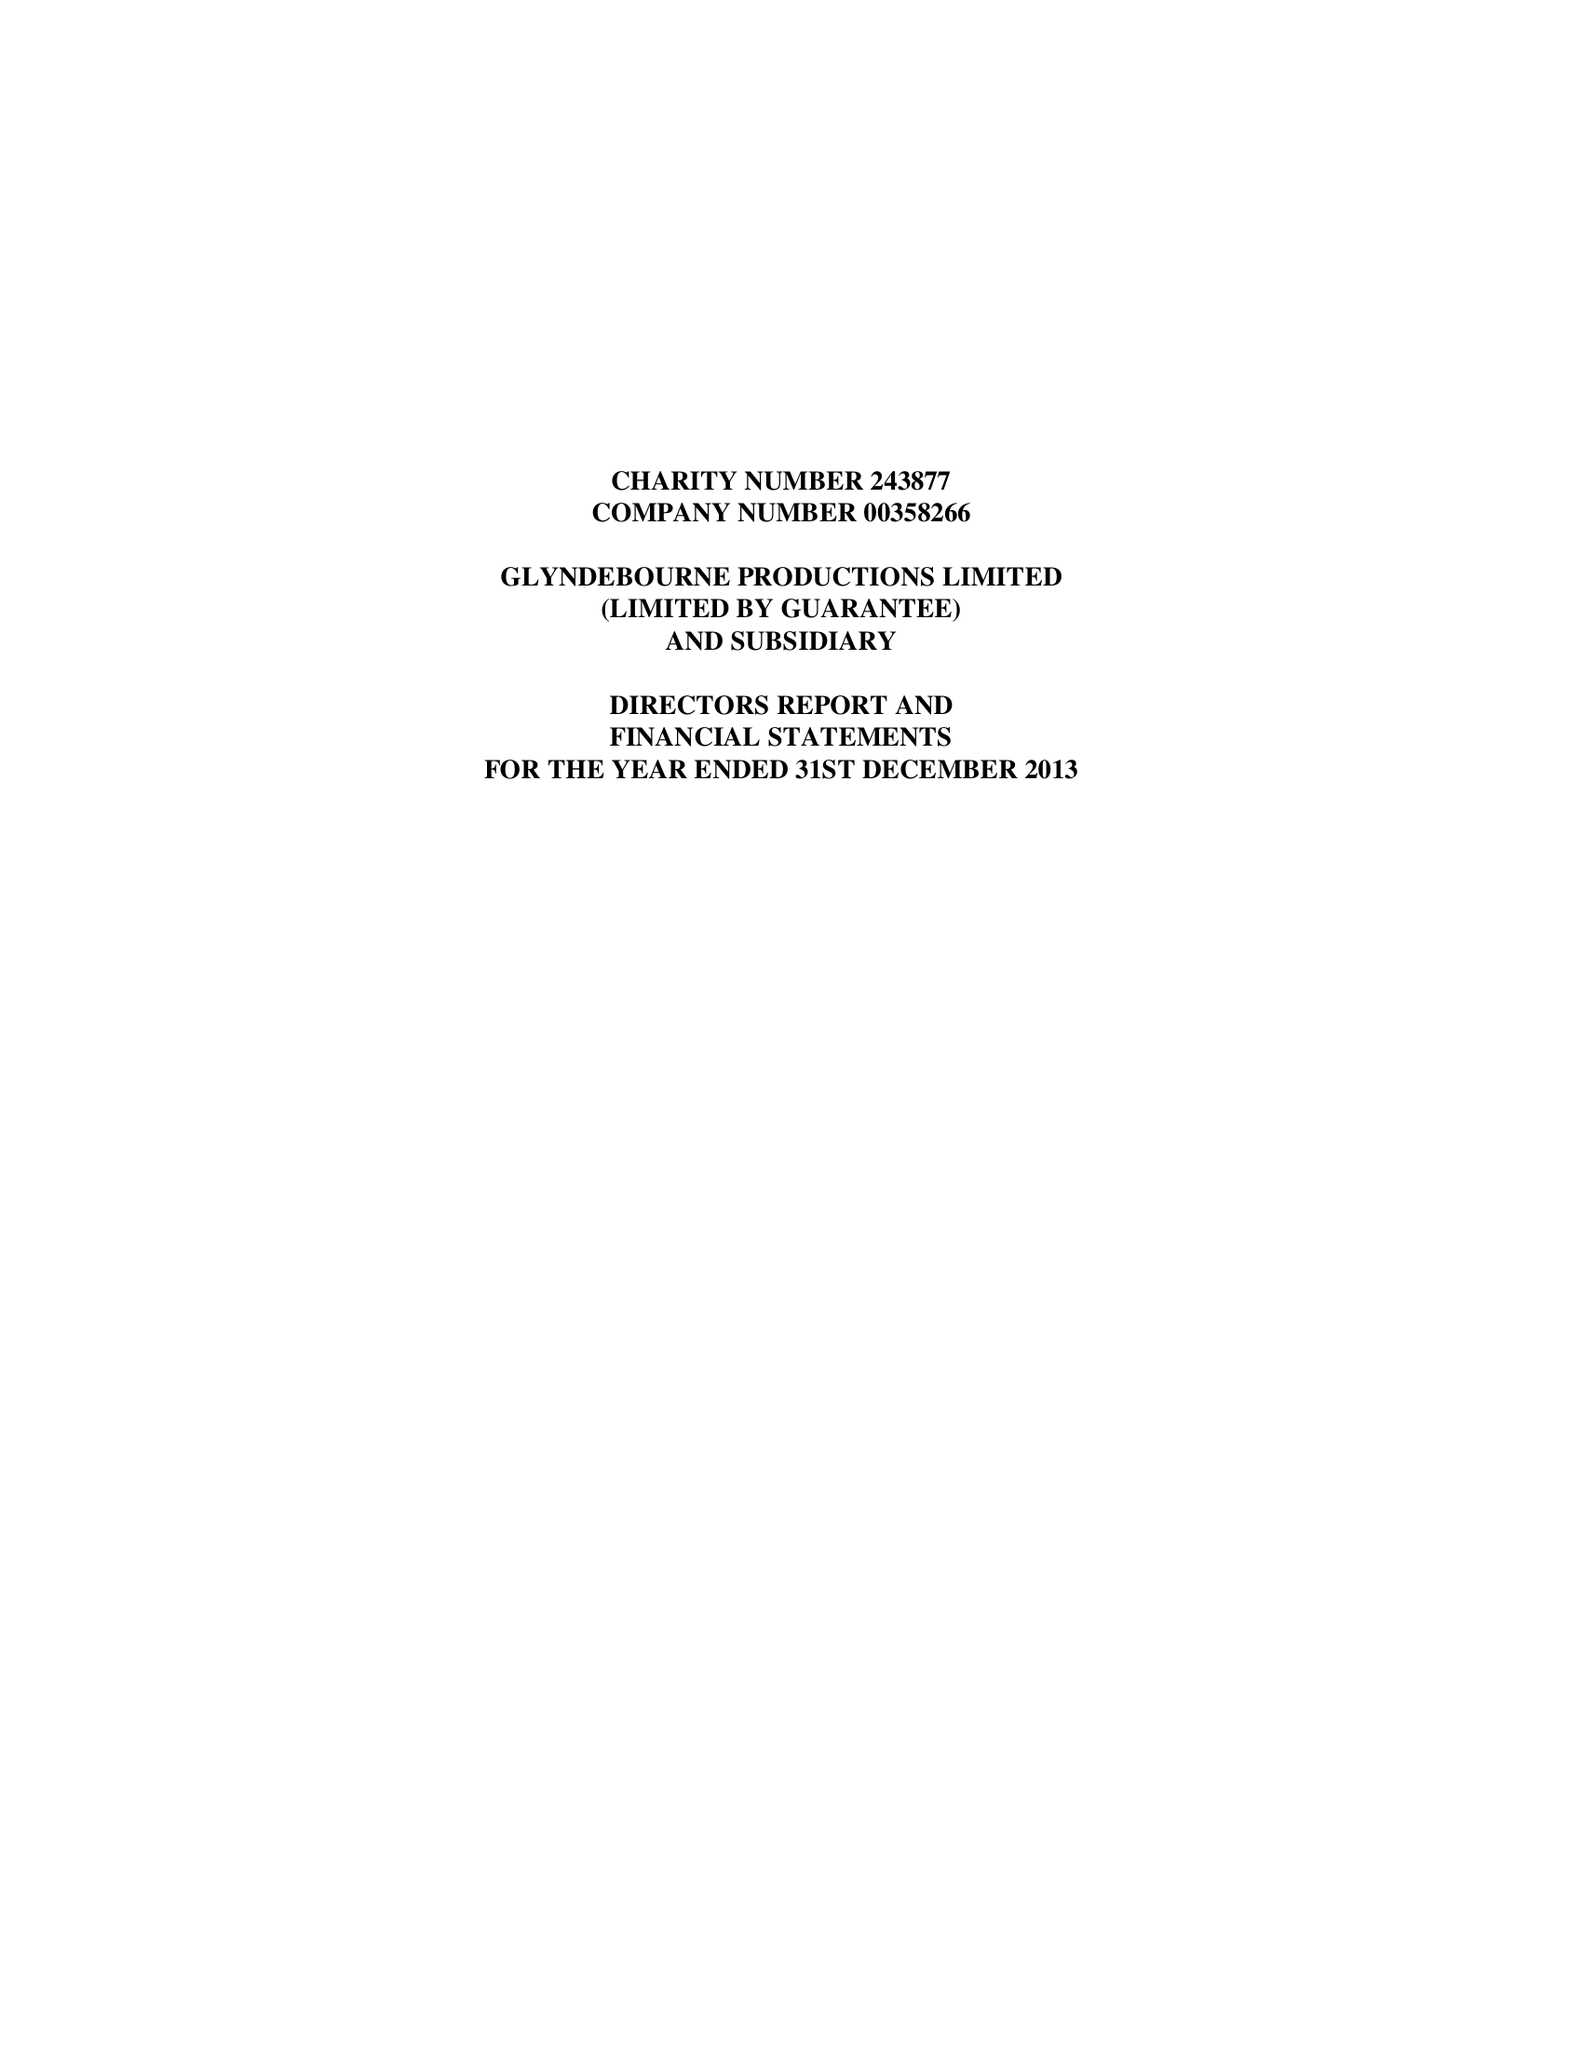What is the value for the spending_annually_in_british_pounds?
Answer the question using a single word or phrase. 25356122.00 